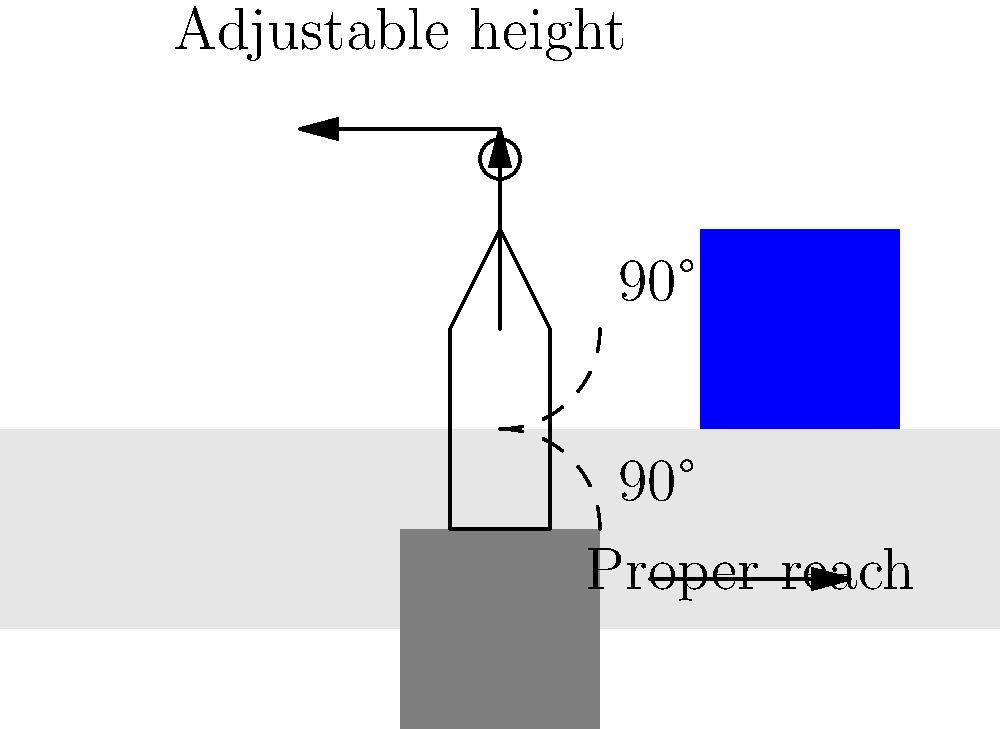In designing an ergonomic workstation to reduce repetitive strain injuries, which of the following is NOT a recommended practice?

A) Maintaining a 90-degree angle at the elbows when typing
B) Keeping the monitor at eye level
C) Using a fixed-height chair for all workers
D) Ensuring proper reach distance to frequently used items Let's analyze each option:

1. Maintaining a 90-degree angle at the elbows when typing:
   This is a recommended practice. It helps reduce strain on the wrists and forearms. In the diagram, we can see the 90-degree angle at the elbow illustrated.

2. Keeping the monitor at eye level:
   This is also recommended. It helps prevent neck strain by avoiding the need to look up or down constantly. The diagram shows the monitor positioned at a proper height.

3. Using a fixed-height chair for all workers:
   This is NOT recommended. Workers have different heights and body proportions. A chair that's comfortable for one worker may cause strain for another. The diagram shows an adjustable chair, indicated by the vertical arrow.

4. Ensuring proper reach distance to frequently used items:
   This is a recommended practice. It reduces the need for overreaching, which can cause strain on the shoulders and back. The horizontal arrow in the diagram illustrates this concept.

Among these options, only C (Using a fixed-height chair for all workers) is not a recommended practice for ergonomic workstation design. Adjustable furniture is crucial to accommodate different body types and sizes, reducing the risk of repetitive strain injuries.
Answer: C) Using a fixed-height chair for all workers 